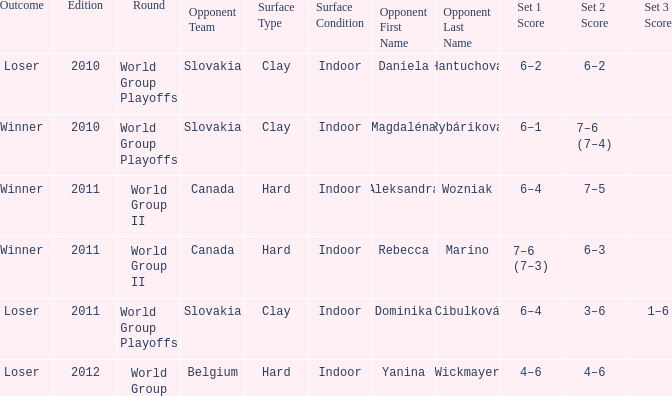What was the game edition during their play on the clay (i) surface, which led to a winning outcome? 2010.0. 